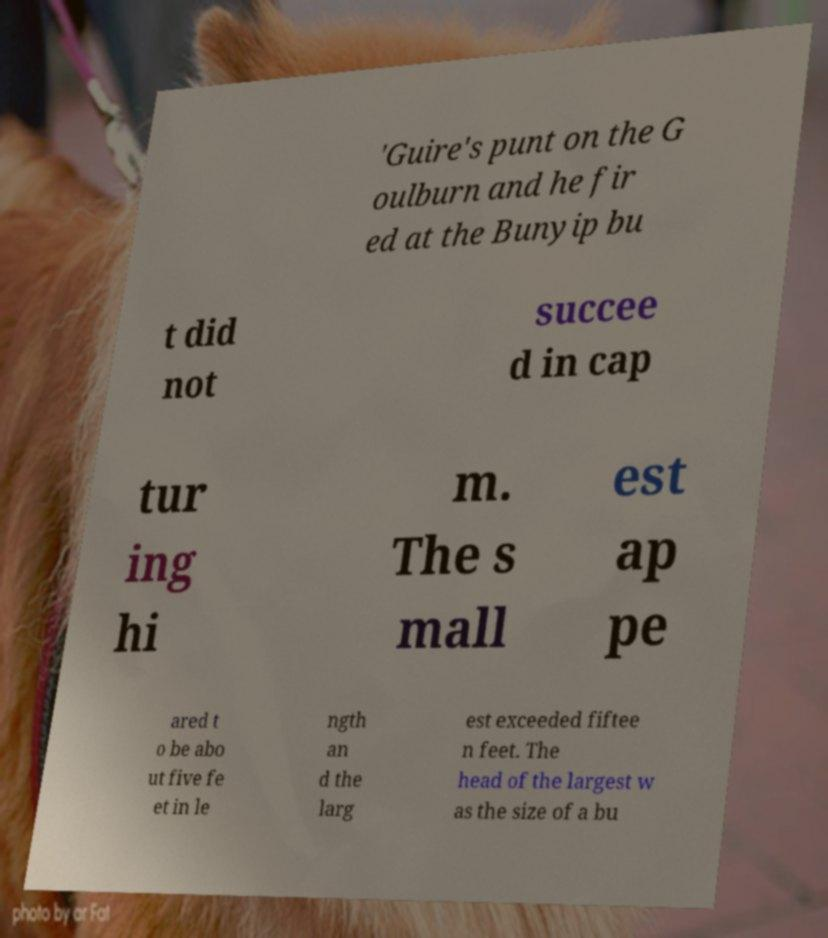Could you assist in decoding the text presented in this image and type it out clearly? 'Guire's punt on the G oulburn and he fir ed at the Bunyip bu t did not succee d in cap tur ing hi m. The s mall est ap pe ared t o be abo ut five fe et in le ngth an d the larg est exceeded fiftee n feet. The head of the largest w as the size of a bu 